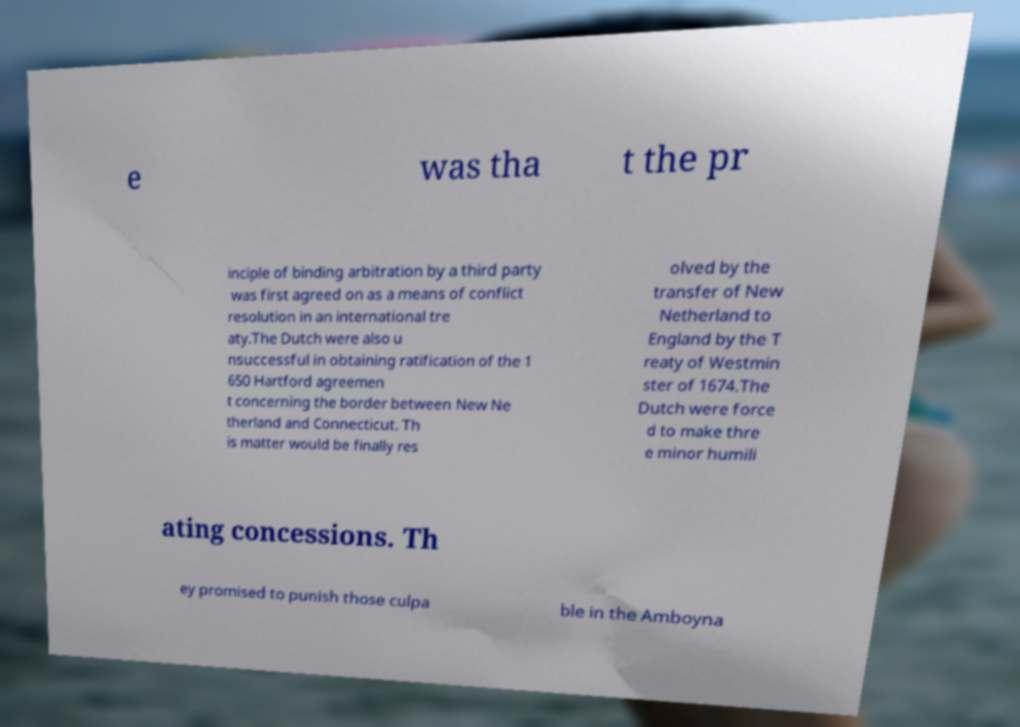Could you extract and type out the text from this image? e was tha t the pr inciple of binding arbitration by a third party was first agreed on as a means of conflict resolution in an international tre aty.The Dutch were also u nsuccessful in obtaining ratification of the 1 650 Hartford agreemen t concerning the border between New Ne therland and Connecticut. Th is matter would be finally res olved by the transfer of New Netherland to England by the T reaty of Westmin ster of 1674.The Dutch were force d to make thre e minor humili ating concessions. Th ey promised to punish those culpa ble in the Amboyna 